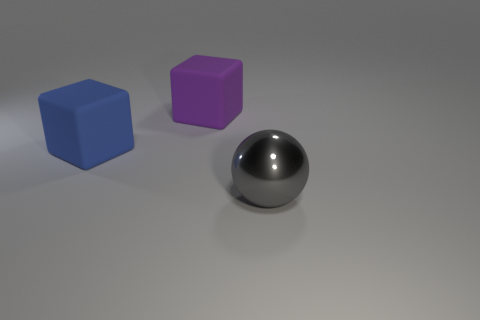Add 2 metal things. How many objects exist? 5 Subtract all cubes. How many objects are left? 1 Subtract all large spheres. Subtract all tiny cylinders. How many objects are left? 2 Add 3 large purple rubber things. How many large purple rubber things are left? 4 Add 3 large green blocks. How many large green blocks exist? 3 Subtract 0 green spheres. How many objects are left? 3 